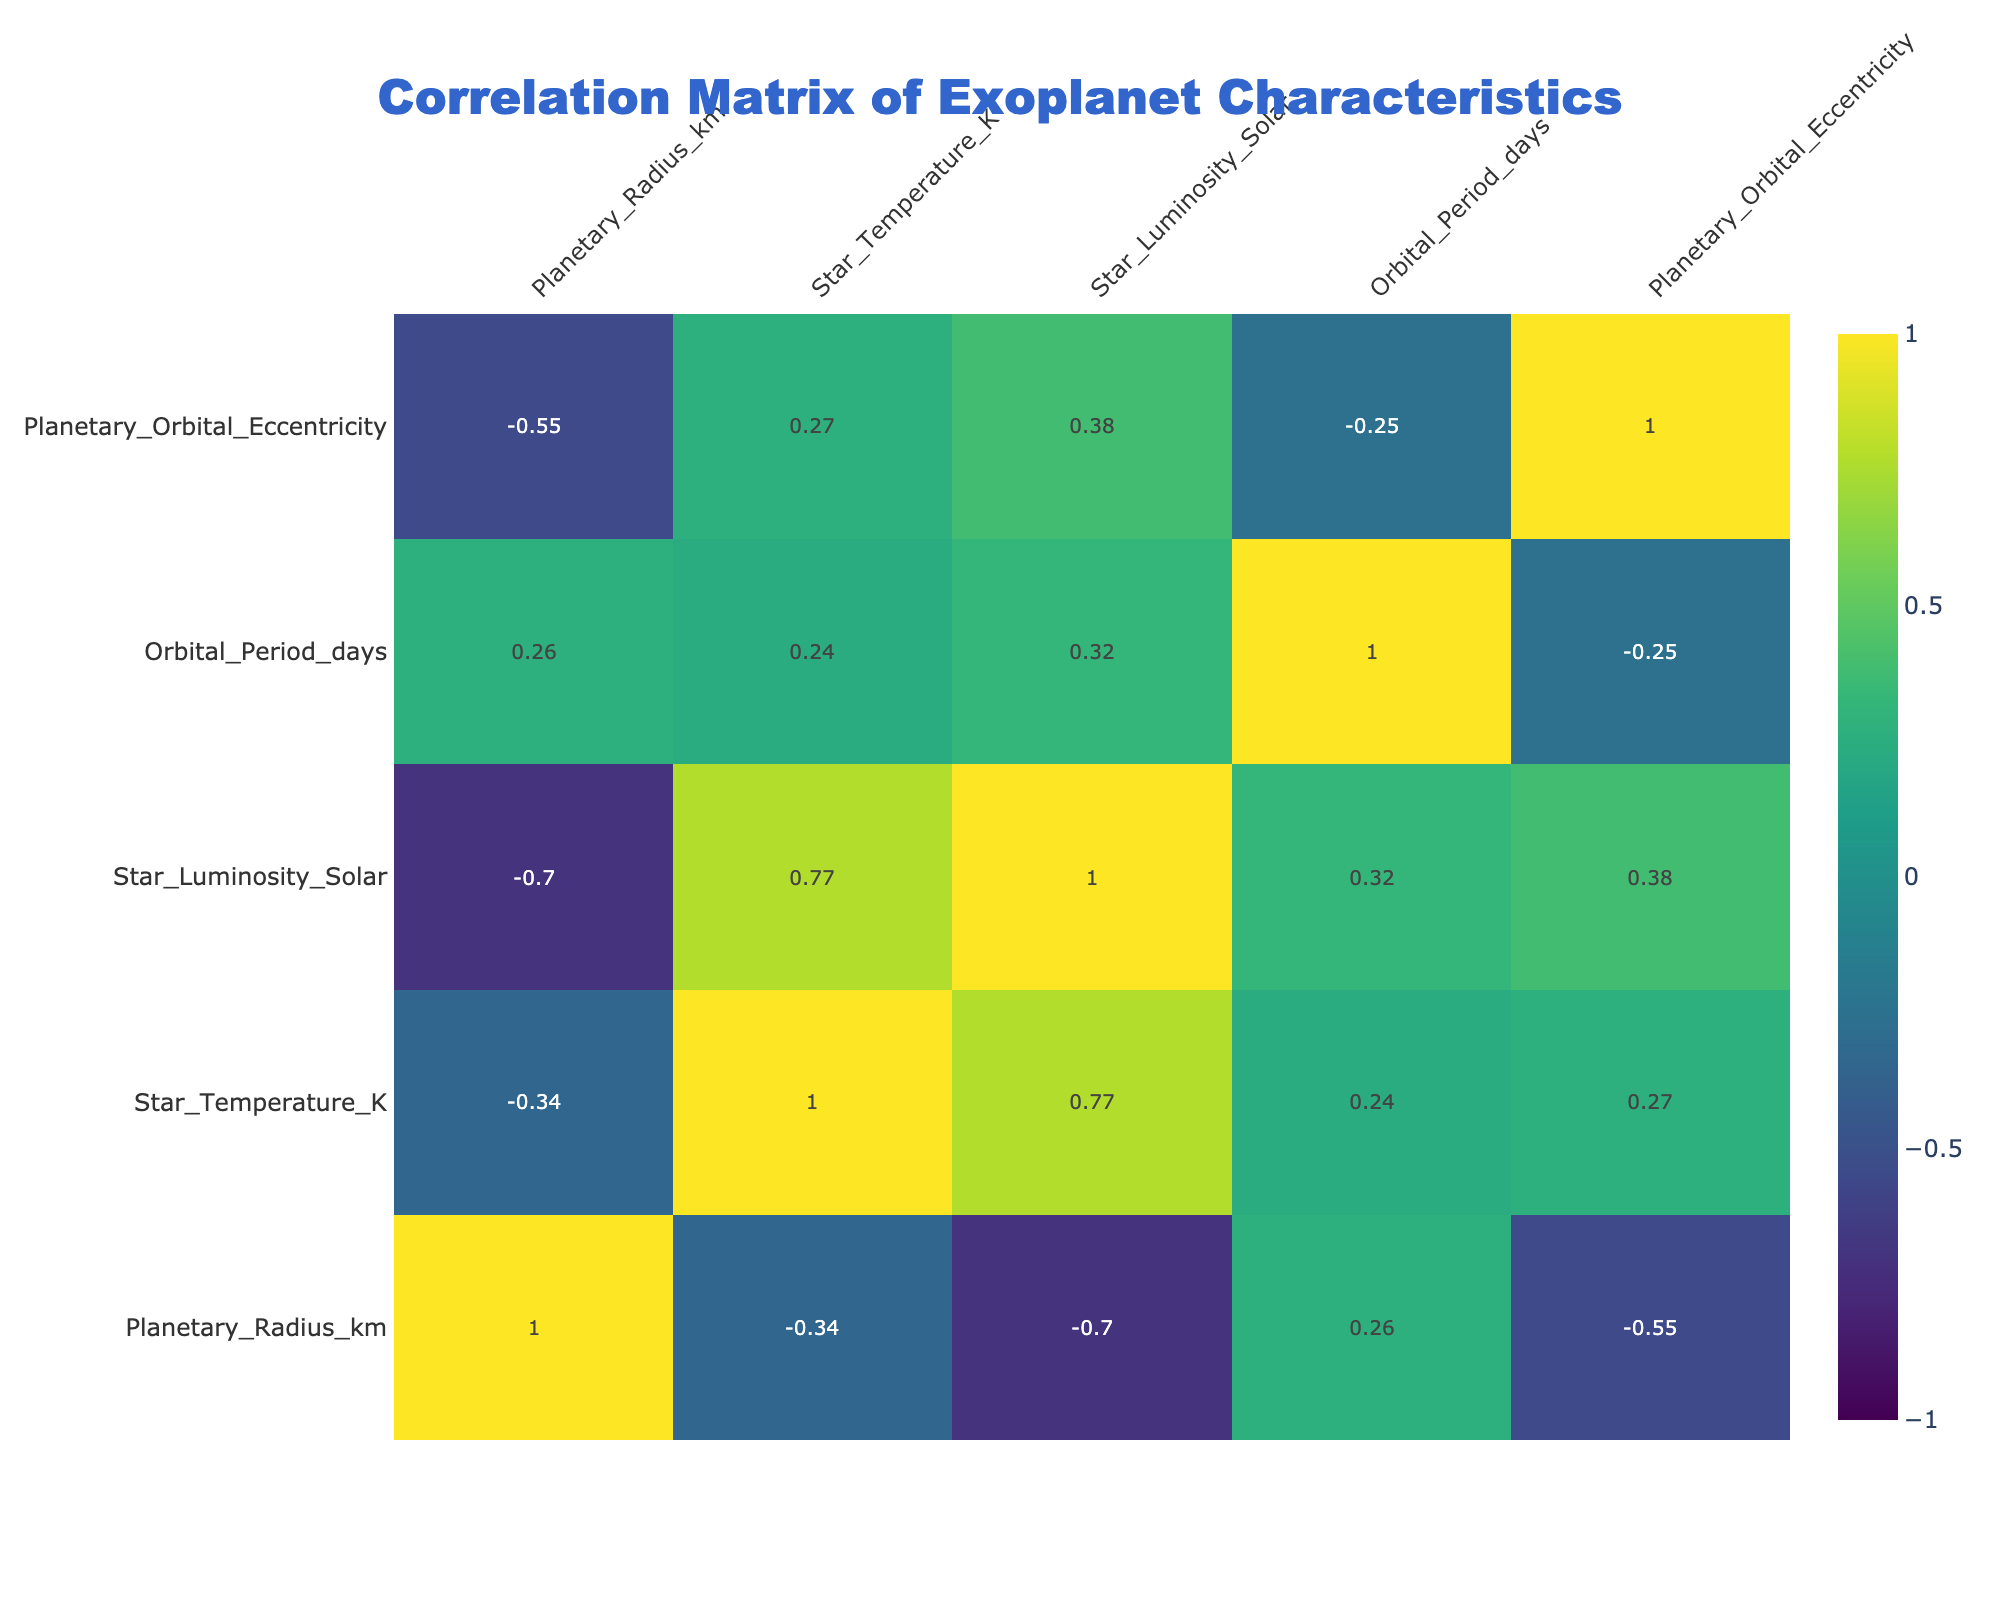What is the orbital period of Proxima Centauri b? From the table, we locate Proxima Centauri b and find that its orbital period is listed under "Orbital_Period_days". The value is 11.2 days.
Answer: 11.2 Which exoplanet has the highest planetary radius in kilometers? We compare the "Planetary_Radius_km" values of all exoplanets in the table. The maximum value appears to be 9100 km for TRAPPIST-1e.
Answer: TRAPPIST-1e What is the average star temperature of the exoplanets listed? We add up the star temperatures (3050 + 2500 + 5600 + 3200 + 6100 + 3500 + 5500 + 6200 = 64,150 K) and divide by the number of exoplanets (8). The average temperature is 64,150 / 8 = 8018.75 K.
Answer: 8018.75 Is there any exoplanet with an orbital eccentricity greater than 0.1? We check the "Planetary_Orbital_Eccentricity" values for each exoplanet in the table. The values for all exoplanets listed are either 0.0, 0.05, or 0.1, indicating none exceed 0.1.
Answer: No What star has the highest luminosity in solar units, and what is its value? Looking through the "Star_Luminosity_Solar" column, we observe that WASP-12 has a luminosity of 0.83 solar units, which is the highest in the list. Other values are lower.
Answer: WASP-12, 0.83 What is the correlation between Star Temperature and Planetary Orbital Period? To determine if there is a correlation, we would examine the correlation coefficient between "Star_Temperature_K" and "Orbital_Period_days". By interpreting the correlation matrix, we find that the correlation coefficient is low, suggesting little to no linear relationship.
Answer: Low correlation How many exoplanets have a planetary orbital period of less than 10 days? We browse through the "Orbital_Period_days" column, counting the entries. Only HD 209458 b (3.52 days) and WASP-12b (1.091 days) are below 10. Thus, there are a total of 2 exoplanets.
Answer: 2 What is the difference in star temperature between the hottest and the coldest star? We find from the table that the hottest star has a temperature of 6200 K (WASP-12) and the coldest is 2500 K (TRAPPIST-1). The difference is 6200 - 2500 = 3700 K.
Answer: 3700 K Do any exoplanets orbit stars that are considerably hotter than 6000 K? We look at the "Star_Temperature_K" values and note that HD 209458 (6100 K) and WASP-12 (6200 K) are both above 6000 K. This confirms the presence of such exoplanets.
Answer: Yes 